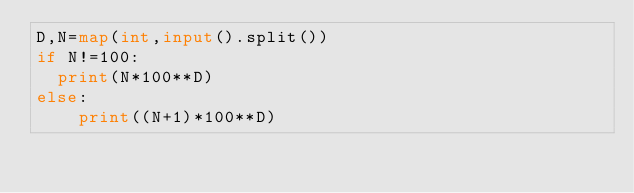<code> <loc_0><loc_0><loc_500><loc_500><_Python_>D,N=map(int,input().split())
if N!=100:
	print(N*100**D)
else:
  	print((N+1)*100**D)
</code> 